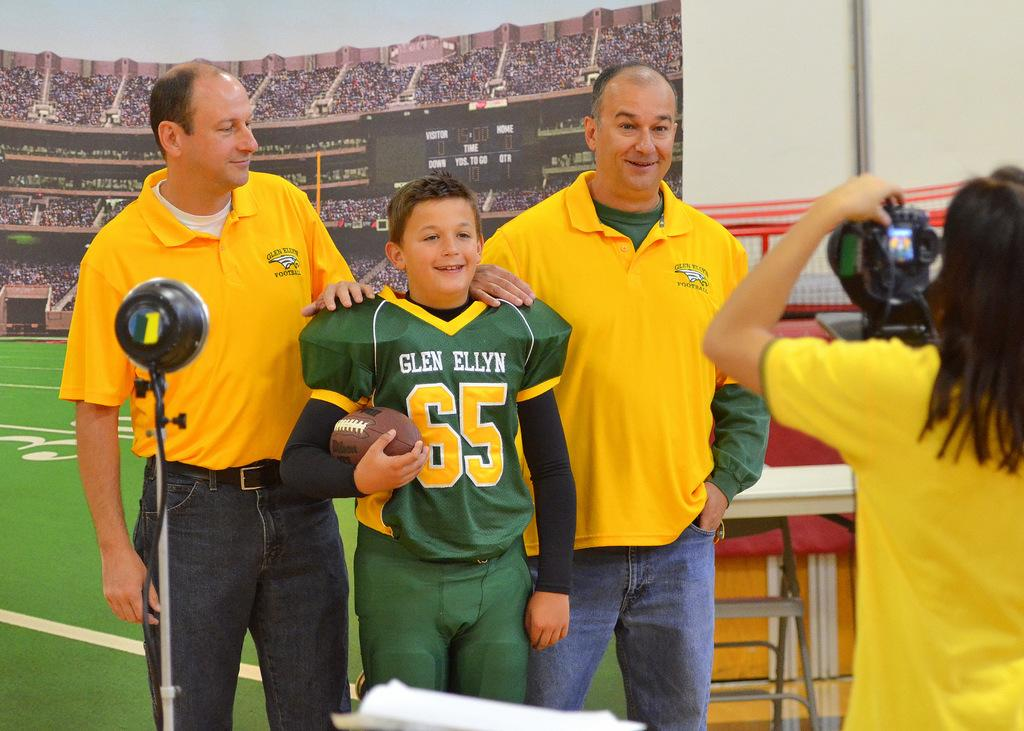<image>
Share a concise interpretation of the image provided. The two  yellow t-shirt persons and one junior rugby player who have a jersey number 65 are give a pose to the photographer 